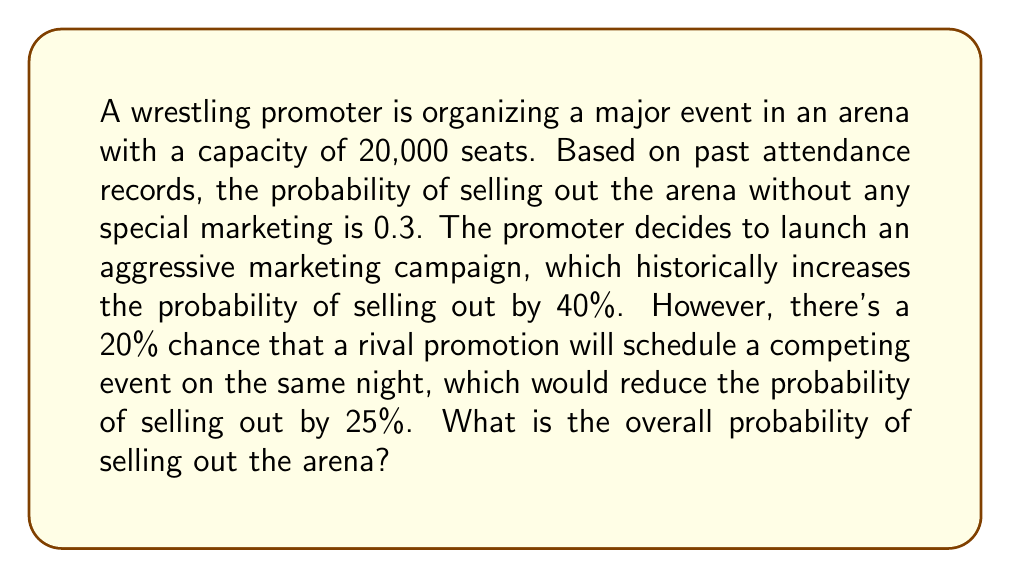Show me your answer to this math problem. Let's approach this step-by-step:

1) First, let's define our probabilities:
   - $P(S)$ = Probability of selling out without marketing = 0.3
   - $P(M)$ = Probability of marketing increasing sales = 1 (certain)
   - $P(C)$ = Probability of competing event = 0.2

2) The effect of marketing:
   - Increases probability by 40%
   - New probability after marketing: $P(S|M) = P(S) \times 1.4 = 0.3 \times 1.4 = 0.42$

3) The effect of the competing event:
   - Reduces probability by 25%
   - Probability if competing event occurs: $P(S|C) = P(S|M) \times 0.75 = 0.42 \times 0.75 = 0.315$

4) Now, we can use the law of total probability:
   $$P(\text{Sellout}) = P(S|M) \times P(\text{No Competition}) + P(S|C) \times P(\text{Competition})$$

5) We know:
   - $P(\text{Competition}) = 0.2$
   - $P(\text{No Competition}) = 1 - 0.2 = 0.8$

6) Plugging in our values:
   $$P(\text{Sellout}) = 0.42 \times 0.8 + 0.315 \times 0.2$$

7) Calculating:
   $$P(\text{Sellout}) = 0.336 + 0.063 = 0.399$$

Therefore, the overall probability of selling out the arena is approximately 0.399 or 39.9%.
Answer: 0.399 